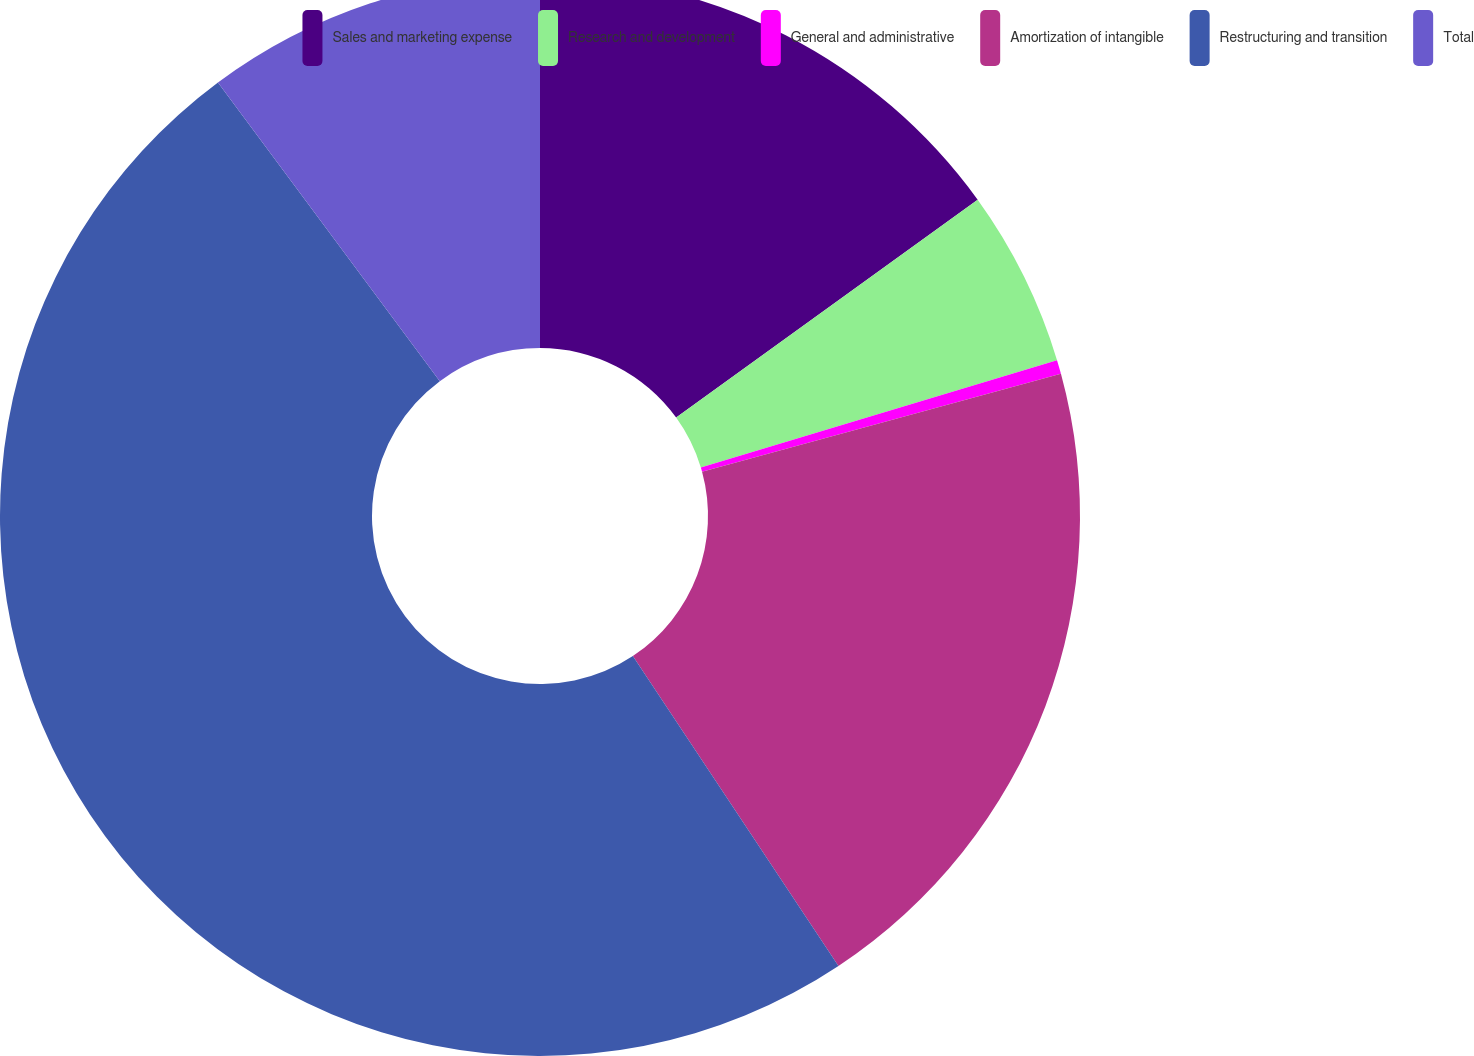Convert chart to OTSL. <chart><loc_0><loc_0><loc_500><loc_500><pie_chart><fcel>Sales and marketing expense<fcel>Research and development<fcel>General and administrative<fcel>Amortization of intangible<fcel>Restructuring and transition<fcel>Total<nl><fcel>15.04%<fcel>5.3%<fcel>0.42%<fcel>19.92%<fcel>49.15%<fcel>10.17%<nl></chart> 